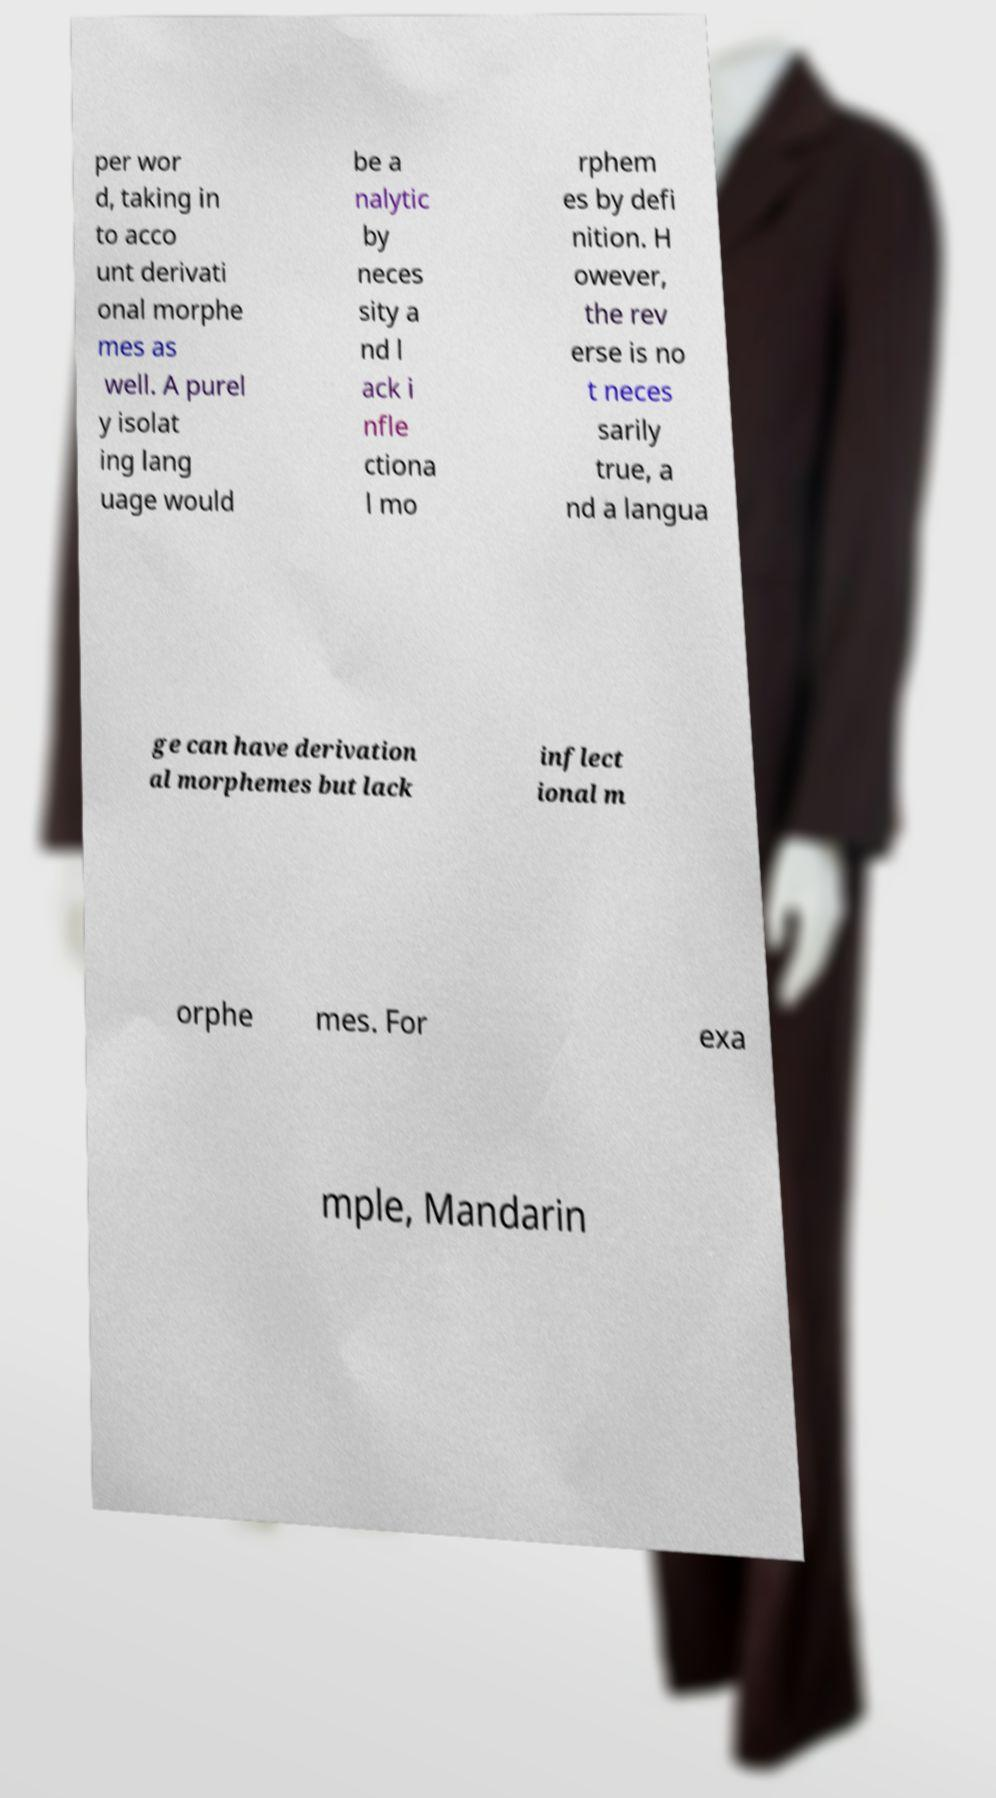Can you read and provide the text displayed in the image?This photo seems to have some interesting text. Can you extract and type it out for me? per wor d, taking in to acco unt derivati onal morphe mes as well. A purel y isolat ing lang uage would be a nalytic by neces sity a nd l ack i nfle ctiona l mo rphem es by defi nition. H owever, the rev erse is no t neces sarily true, a nd a langua ge can have derivation al morphemes but lack inflect ional m orphe mes. For exa mple, Mandarin 